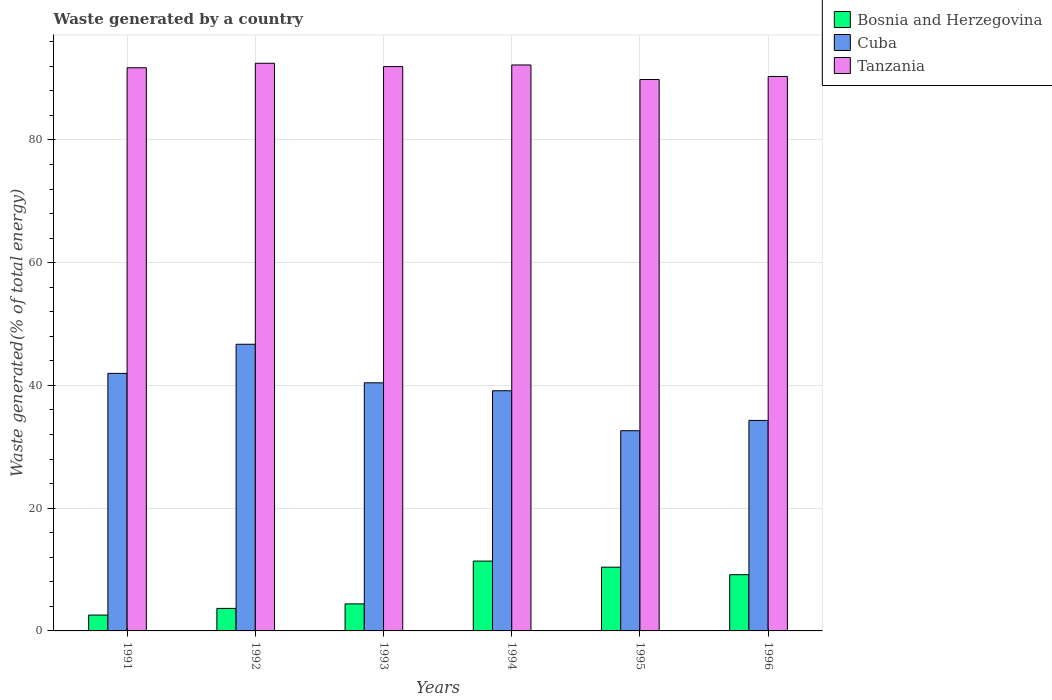How many different coloured bars are there?
Your response must be concise. 3. What is the total waste generated in Bosnia and Herzegovina in 1994?
Provide a short and direct response. 11.38. Across all years, what is the maximum total waste generated in Cuba?
Your answer should be compact. 46.7. Across all years, what is the minimum total waste generated in Bosnia and Herzegovina?
Offer a very short reply. 2.59. In which year was the total waste generated in Cuba maximum?
Your answer should be very brief. 1992. What is the total total waste generated in Cuba in the graph?
Your response must be concise. 235.14. What is the difference between the total waste generated in Tanzania in 1994 and that in 1996?
Provide a short and direct response. 1.87. What is the difference between the total waste generated in Cuba in 1991 and the total waste generated in Bosnia and Herzegovina in 1995?
Provide a short and direct response. 31.57. What is the average total waste generated in Tanzania per year?
Offer a very short reply. 91.43. In the year 1991, what is the difference between the total waste generated in Cuba and total waste generated in Tanzania?
Offer a terse response. -49.79. In how many years, is the total waste generated in Tanzania greater than 32 %?
Ensure brevity in your answer.  6. What is the ratio of the total waste generated in Cuba in 1991 to that in 1994?
Give a very brief answer. 1.07. What is the difference between the highest and the second highest total waste generated in Tanzania?
Offer a terse response. 0.28. What is the difference between the highest and the lowest total waste generated in Tanzania?
Ensure brevity in your answer.  2.65. Is the sum of the total waste generated in Bosnia and Herzegovina in 1991 and 1994 greater than the maximum total waste generated in Tanzania across all years?
Ensure brevity in your answer.  No. What does the 3rd bar from the left in 1996 represents?
Make the answer very short. Tanzania. What does the 2nd bar from the right in 1993 represents?
Provide a short and direct response. Cuba. How many bars are there?
Your response must be concise. 18. How many years are there in the graph?
Offer a very short reply. 6. Are the values on the major ticks of Y-axis written in scientific E-notation?
Your response must be concise. No. Does the graph contain any zero values?
Your response must be concise. No. Does the graph contain grids?
Your answer should be very brief. Yes. Where does the legend appear in the graph?
Ensure brevity in your answer.  Top right. How are the legend labels stacked?
Provide a short and direct response. Vertical. What is the title of the graph?
Offer a very short reply. Waste generated by a country. What is the label or title of the X-axis?
Provide a short and direct response. Years. What is the label or title of the Y-axis?
Provide a succinct answer. Waste generated(% of total energy). What is the Waste generated(% of total energy) of Bosnia and Herzegovina in 1991?
Provide a short and direct response. 2.59. What is the Waste generated(% of total energy) in Cuba in 1991?
Offer a very short reply. 41.96. What is the Waste generated(% of total energy) of Tanzania in 1991?
Offer a very short reply. 91.75. What is the Waste generated(% of total energy) in Bosnia and Herzegovina in 1992?
Your answer should be very brief. 3.67. What is the Waste generated(% of total energy) of Cuba in 1992?
Provide a succinct answer. 46.7. What is the Waste generated(% of total energy) of Tanzania in 1992?
Your answer should be very brief. 92.49. What is the Waste generated(% of total energy) of Bosnia and Herzegovina in 1993?
Keep it short and to the point. 4.41. What is the Waste generated(% of total energy) in Cuba in 1993?
Your answer should be very brief. 40.42. What is the Waste generated(% of total energy) of Tanzania in 1993?
Keep it short and to the point. 91.94. What is the Waste generated(% of total energy) of Bosnia and Herzegovina in 1994?
Keep it short and to the point. 11.38. What is the Waste generated(% of total energy) of Cuba in 1994?
Offer a very short reply. 39.13. What is the Waste generated(% of total energy) in Tanzania in 1994?
Keep it short and to the point. 92.21. What is the Waste generated(% of total energy) in Bosnia and Herzegovina in 1995?
Make the answer very short. 10.39. What is the Waste generated(% of total energy) in Cuba in 1995?
Your answer should be compact. 32.62. What is the Waste generated(% of total energy) in Tanzania in 1995?
Your answer should be compact. 89.84. What is the Waste generated(% of total energy) in Bosnia and Herzegovina in 1996?
Your answer should be compact. 9.16. What is the Waste generated(% of total energy) in Cuba in 1996?
Make the answer very short. 34.3. What is the Waste generated(% of total energy) of Tanzania in 1996?
Provide a short and direct response. 90.34. Across all years, what is the maximum Waste generated(% of total energy) of Bosnia and Herzegovina?
Provide a succinct answer. 11.38. Across all years, what is the maximum Waste generated(% of total energy) in Cuba?
Your response must be concise. 46.7. Across all years, what is the maximum Waste generated(% of total energy) of Tanzania?
Offer a terse response. 92.49. Across all years, what is the minimum Waste generated(% of total energy) in Bosnia and Herzegovina?
Keep it short and to the point. 2.59. Across all years, what is the minimum Waste generated(% of total energy) of Cuba?
Your answer should be compact. 32.62. Across all years, what is the minimum Waste generated(% of total energy) in Tanzania?
Ensure brevity in your answer.  89.84. What is the total Waste generated(% of total energy) in Bosnia and Herzegovina in the graph?
Offer a very short reply. 41.59. What is the total Waste generated(% of total energy) of Cuba in the graph?
Keep it short and to the point. 235.14. What is the total Waste generated(% of total energy) in Tanzania in the graph?
Offer a terse response. 548.57. What is the difference between the Waste generated(% of total energy) in Bosnia and Herzegovina in 1991 and that in 1992?
Your response must be concise. -1.09. What is the difference between the Waste generated(% of total energy) of Cuba in 1991 and that in 1992?
Your response must be concise. -4.74. What is the difference between the Waste generated(% of total energy) of Tanzania in 1991 and that in 1992?
Your answer should be compact. -0.73. What is the difference between the Waste generated(% of total energy) in Bosnia and Herzegovina in 1991 and that in 1993?
Your answer should be compact. -1.82. What is the difference between the Waste generated(% of total energy) of Cuba in 1991 and that in 1993?
Offer a very short reply. 1.54. What is the difference between the Waste generated(% of total energy) of Tanzania in 1991 and that in 1993?
Provide a short and direct response. -0.19. What is the difference between the Waste generated(% of total energy) in Bosnia and Herzegovina in 1991 and that in 1994?
Ensure brevity in your answer.  -8.79. What is the difference between the Waste generated(% of total energy) of Cuba in 1991 and that in 1994?
Give a very brief answer. 2.83. What is the difference between the Waste generated(% of total energy) in Tanzania in 1991 and that in 1994?
Your answer should be compact. -0.46. What is the difference between the Waste generated(% of total energy) of Bosnia and Herzegovina in 1991 and that in 1995?
Provide a short and direct response. -7.8. What is the difference between the Waste generated(% of total energy) in Cuba in 1991 and that in 1995?
Your answer should be very brief. 9.34. What is the difference between the Waste generated(% of total energy) in Tanzania in 1991 and that in 1995?
Provide a succinct answer. 1.92. What is the difference between the Waste generated(% of total energy) in Bosnia and Herzegovina in 1991 and that in 1996?
Ensure brevity in your answer.  -6.58. What is the difference between the Waste generated(% of total energy) in Cuba in 1991 and that in 1996?
Your answer should be very brief. 7.66. What is the difference between the Waste generated(% of total energy) of Tanzania in 1991 and that in 1996?
Ensure brevity in your answer.  1.42. What is the difference between the Waste generated(% of total energy) in Bosnia and Herzegovina in 1992 and that in 1993?
Make the answer very short. -0.74. What is the difference between the Waste generated(% of total energy) in Cuba in 1992 and that in 1993?
Your answer should be very brief. 6.28. What is the difference between the Waste generated(% of total energy) of Tanzania in 1992 and that in 1993?
Ensure brevity in your answer.  0.54. What is the difference between the Waste generated(% of total energy) in Bosnia and Herzegovina in 1992 and that in 1994?
Keep it short and to the point. -7.71. What is the difference between the Waste generated(% of total energy) of Cuba in 1992 and that in 1994?
Provide a short and direct response. 7.57. What is the difference between the Waste generated(% of total energy) in Tanzania in 1992 and that in 1994?
Provide a succinct answer. 0.28. What is the difference between the Waste generated(% of total energy) of Bosnia and Herzegovina in 1992 and that in 1995?
Provide a succinct answer. -6.72. What is the difference between the Waste generated(% of total energy) of Cuba in 1992 and that in 1995?
Provide a short and direct response. 14.08. What is the difference between the Waste generated(% of total energy) of Tanzania in 1992 and that in 1995?
Offer a very short reply. 2.65. What is the difference between the Waste generated(% of total energy) in Bosnia and Herzegovina in 1992 and that in 1996?
Provide a short and direct response. -5.49. What is the difference between the Waste generated(% of total energy) of Cuba in 1992 and that in 1996?
Your response must be concise. 12.41. What is the difference between the Waste generated(% of total energy) of Tanzania in 1992 and that in 1996?
Your answer should be compact. 2.15. What is the difference between the Waste generated(% of total energy) of Bosnia and Herzegovina in 1993 and that in 1994?
Provide a short and direct response. -6.97. What is the difference between the Waste generated(% of total energy) of Cuba in 1993 and that in 1994?
Offer a terse response. 1.29. What is the difference between the Waste generated(% of total energy) in Tanzania in 1993 and that in 1994?
Provide a short and direct response. -0.26. What is the difference between the Waste generated(% of total energy) in Bosnia and Herzegovina in 1993 and that in 1995?
Give a very brief answer. -5.98. What is the difference between the Waste generated(% of total energy) in Cuba in 1993 and that in 1995?
Make the answer very short. 7.8. What is the difference between the Waste generated(% of total energy) of Tanzania in 1993 and that in 1995?
Ensure brevity in your answer.  2.11. What is the difference between the Waste generated(% of total energy) in Bosnia and Herzegovina in 1993 and that in 1996?
Keep it short and to the point. -4.76. What is the difference between the Waste generated(% of total energy) of Cuba in 1993 and that in 1996?
Ensure brevity in your answer.  6.13. What is the difference between the Waste generated(% of total energy) in Tanzania in 1993 and that in 1996?
Your answer should be compact. 1.61. What is the difference between the Waste generated(% of total energy) of Bosnia and Herzegovina in 1994 and that in 1995?
Provide a succinct answer. 0.99. What is the difference between the Waste generated(% of total energy) in Cuba in 1994 and that in 1995?
Your answer should be very brief. 6.51. What is the difference between the Waste generated(% of total energy) of Tanzania in 1994 and that in 1995?
Keep it short and to the point. 2.37. What is the difference between the Waste generated(% of total energy) in Bosnia and Herzegovina in 1994 and that in 1996?
Offer a very short reply. 2.22. What is the difference between the Waste generated(% of total energy) in Cuba in 1994 and that in 1996?
Your response must be concise. 4.83. What is the difference between the Waste generated(% of total energy) of Tanzania in 1994 and that in 1996?
Ensure brevity in your answer.  1.87. What is the difference between the Waste generated(% of total energy) of Bosnia and Herzegovina in 1995 and that in 1996?
Keep it short and to the point. 1.23. What is the difference between the Waste generated(% of total energy) of Cuba in 1995 and that in 1996?
Offer a terse response. -1.68. What is the difference between the Waste generated(% of total energy) in Tanzania in 1995 and that in 1996?
Keep it short and to the point. -0.5. What is the difference between the Waste generated(% of total energy) of Bosnia and Herzegovina in 1991 and the Waste generated(% of total energy) of Cuba in 1992?
Provide a succinct answer. -44.12. What is the difference between the Waste generated(% of total energy) in Bosnia and Herzegovina in 1991 and the Waste generated(% of total energy) in Tanzania in 1992?
Keep it short and to the point. -89.9. What is the difference between the Waste generated(% of total energy) in Cuba in 1991 and the Waste generated(% of total energy) in Tanzania in 1992?
Make the answer very short. -50.52. What is the difference between the Waste generated(% of total energy) of Bosnia and Herzegovina in 1991 and the Waste generated(% of total energy) of Cuba in 1993?
Provide a succinct answer. -37.84. What is the difference between the Waste generated(% of total energy) of Bosnia and Herzegovina in 1991 and the Waste generated(% of total energy) of Tanzania in 1993?
Keep it short and to the point. -89.36. What is the difference between the Waste generated(% of total energy) of Cuba in 1991 and the Waste generated(% of total energy) of Tanzania in 1993?
Give a very brief answer. -49.98. What is the difference between the Waste generated(% of total energy) in Bosnia and Herzegovina in 1991 and the Waste generated(% of total energy) in Cuba in 1994?
Provide a succinct answer. -36.55. What is the difference between the Waste generated(% of total energy) in Bosnia and Herzegovina in 1991 and the Waste generated(% of total energy) in Tanzania in 1994?
Your answer should be very brief. -89.62. What is the difference between the Waste generated(% of total energy) in Cuba in 1991 and the Waste generated(% of total energy) in Tanzania in 1994?
Ensure brevity in your answer.  -50.25. What is the difference between the Waste generated(% of total energy) in Bosnia and Herzegovina in 1991 and the Waste generated(% of total energy) in Cuba in 1995?
Offer a very short reply. -30.03. What is the difference between the Waste generated(% of total energy) of Bosnia and Herzegovina in 1991 and the Waste generated(% of total energy) of Tanzania in 1995?
Provide a succinct answer. -87.25. What is the difference between the Waste generated(% of total energy) of Cuba in 1991 and the Waste generated(% of total energy) of Tanzania in 1995?
Your answer should be very brief. -47.87. What is the difference between the Waste generated(% of total energy) of Bosnia and Herzegovina in 1991 and the Waste generated(% of total energy) of Cuba in 1996?
Provide a short and direct response. -31.71. What is the difference between the Waste generated(% of total energy) of Bosnia and Herzegovina in 1991 and the Waste generated(% of total energy) of Tanzania in 1996?
Ensure brevity in your answer.  -87.75. What is the difference between the Waste generated(% of total energy) of Cuba in 1991 and the Waste generated(% of total energy) of Tanzania in 1996?
Offer a very short reply. -48.37. What is the difference between the Waste generated(% of total energy) of Bosnia and Herzegovina in 1992 and the Waste generated(% of total energy) of Cuba in 1993?
Make the answer very short. -36.75. What is the difference between the Waste generated(% of total energy) in Bosnia and Herzegovina in 1992 and the Waste generated(% of total energy) in Tanzania in 1993?
Make the answer very short. -88.27. What is the difference between the Waste generated(% of total energy) in Cuba in 1992 and the Waste generated(% of total energy) in Tanzania in 1993?
Provide a short and direct response. -45.24. What is the difference between the Waste generated(% of total energy) of Bosnia and Herzegovina in 1992 and the Waste generated(% of total energy) of Cuba in 1994?
Your answer should be compact. -35.46. What is the difference between the Waste generated(% of total energy) in Bosnia and Herzegovina in 1992 and the Waste generated(% of total energy) in Tanzania in 1994?
Offer a very short reply. -88.54. What is the difference between the Waste generated(% of total energy) of Cuba in 1992 and the Waste generated(% of total energy) of Tanzania in 1994?
Offer a terse response. -45.5. What is the difference between the Waste generated(% of total energy) of Bosnia and Herzegovina in 1992 and the Waste generated(% of total energy) of Cuba in 1995?
Keep it short and to the point. -28.95. What is the difference between the Waste generated(% of total energy) in Bosnia and Herzegovina in 1992 and the Waste generated(% of total energy) in Tanzania in 1995?
Your answer should be very brief. -86.17. What is the difference between the Waste generated(% of total energy) of Cuba in 1992 and the Waste generated(% of total energy) of Tanzania in 1995?
Provide a short and direct response. -43.13. What is the difference between the Waste generated(% of total energy) of Bosnia and Herzegovina in 1992 and the Waste generated(% of total energy) of Cuba in 1996?
Offer a terse response. -30.63. What is the difference between the Waste generated(% of total energy) in Bosnia and Herzegovina in 1992 and the Waste generated(% of total energy) in Tanzania in 1996?
Give a very brief answer. -86.67. What is the difference between the Waste generated(% of total energy) of Cuba in 1992 and the Waste generated(% of total energy) of Tanzania in 1996?
Provide a succinct answer. -43.63. What is the difference between the Waste generated(% of total energy) of Bosnia and Herzegovina in 1993 and the Waste generated(% of total energy) of Cuba in 1994?
Give a very brief answer. -34.73. What is the difference between the Waste generated(% of total energy) of Bosnia and Herzegovina in 1993 and the Waste generated(% of total energy) of Tanzania in 1994?
Offer a terse response. -87.8. What is the difference between the Waste generated(% of total energy) of Cuba in 1993 and the Waste generated(% of total energy) of Tanzania in 1994?
Your answer should be very brief. -51.78. What is the difference between the Waste generated(% of total energy) of Bosnia and Herzegovina in 1993 and the Waste generated(% of total energy) of Cuba in 1995?
Keep it short and to the point. -28.21. What is the difference between the Waste generated(% of total energy) in Bosnia and Herzegovina in 1993 and the Waste generated(% of total energy) in Tanzania in 1995?
Offer a terse response. -85.43. What is the difference between the Waste generated(% of total energy) of Cuba in 1993 and the Waste generated(% of total energy) of Tanzania in 1995?
Make the answer very short. -49.41. What is the difference between the Waste generated(% of total energy) of Bosnia and Herzegovina in 1993 and the Waste generated(% of total energy) of Cuba in 1996?
Your answer should be very brief. -29.89. What is the difference between the Waste generated(% of total energy) of Bosnia and Herzegovina in 1993 and the Waste generated(% of total energy) of Tanzania in 1996?
Offer a terse response. -85.93. What is the difference between the Waste generated(% of total energy) of Cuba in 1993 and the Waste generated(% of total energy) of Tanzania in 1996?
Ensure brevity in your answer.  -49.91. What is the difference between the Waste generated(% of total energy) of Bosnia and Herzegovina in 1994 and the Waste generated(% of total energy) of Cuba in 1995?
Ensure brevity in your answer.  -21.24. What is the difference between the Waste generated(% of total energy) of Bosnia and Herzegovina in 1994 and the Waste generated(% of total energy) of Tanzania in 1995?
Keep it short and to the point. -78.46. What is the difference between the Waste generated(% of total energy) in Cuba in 1994 and the Waste generated(% of total energy) in Tanzania in 1995?
Ensure brevity in your answer.  -50.71. What is the difference between the Waste generated(% of total energy) of Bosnia and Herzegovina in 1994 and the Waste generated(% of total energy) of Cuba in 1996?
Offer a very short reply. -22.92. What is the difference between the Waste generated(% of total energy) of Bosnia and Herzegovina in 1994 and the Waste generated(% of total energy) of Tanzania in 1996?
Make the answer very short. -78.96. What is the difference between the Waste generated(% of total energy) of Cuba in 1994 and the Waste generated(% of total energy) of Tanzania in 1996?
Your answer should be compact. -51.21. What is the difference between the Waste generated(% of total energy) in Bosnia and Herzegovina in 1995 and the Waste generated(% of total energy) in Cuba in 1996?
Offer a very short reply. -23.91. What is the difference between the Waste generated(% of total energy) in Bosnia and Herzegovina in 1995 and the Waste generated(% of total energy) in Tanzania in 1996?
Make the answer very short. -79.95. What is the difference between the Waste generated(% of total energy) in Cuba in 1995 and the Waste generated(% of total energy) in Tanzania in 1996?
Your response must be concise. -57.72. What is the average Waste generated(% of total energy) of Bosnia and Herzegovina per year?
Your response must be concise. 6.93. What is the average Waste generated(% of total energy) of Cuba per year?
Your answer should be compact. 39.19. What is the average Waste generated(% of total energy) of Tanzania per year?
Offer a terse response. 91.43. In the year 1991, what is the difference between the Waste generated(% of total energy) of Bosnia and Herzegovina and Waste generated(% of total energy) of Cuba?
Provide a succinct answer. -39.38. In the year 1991, what is the difference between the Waste generated(% of total energy) in Bosnia and Herzegovina and Waste generated(% of total energy) in Tanzania?
Offer a very short reply. -89.17. In the year 1991, what is the difference between the Waste generated(% of total energy) of Cuba and Waste generated(% of total energy) of Tanzania?
Keep it short and to the point. -49.79. In the year 1992, what is the difference between the Waste generated(% of total energy) of Bosnia and Herzegovina and Waste generated(% of total energy) of Cuba?
Provide a succinct answer. -43.03. In the year 1992, what is the difference between the Waste generated(% of total energy) in Bosnia and Herzegovina and Waste generated(% of total energy) in Tanzania?
Your answer should be very brief. -88.82. In the year 1992, what is the difference between the Waste generated(% of total energy) in Cuba and Waste generated(% of total energy) in Tanzania?
Offer a terse response. -45.78. In the year 1993, what is the difference between the Waste generated(% of total energy) in Bosnia and Herzegovina and Waste generated(% of total energy) in Cuba?
Give a very brief answer. -36.02. In the year 1993, what is the difference between the Waste generated(% of total energy) in Bosnia and Herzegovina and Waste generated(% of total energy) in Tanzania?
Ensure brevity in your answer.  -87.54. In the year 1993, what is the difference between the Waste generated(% of total energy) of Cuba and Waste generated(% of total energy) of Tanzania?
Ensure brevity in your answer.  -51.52. In the year 1994, what is the difference between the Waste generated(% of total energy) of Bosnia and Herzegovina and Waste generated(% of total energy) of Cuba?
Your response must be concise. -27.75. In the year 1994, what is the difference between the Waste generated(% of total energy) in Bosnia and Herzegovina and Waste generated(% of total energy) in Tanzania?
Your response must be concise. -80.83. In the year 1994, what is the difference between the Waste generated(% of total energy) of Cuba and Waste generated(% of total energy) of Tanzania?
Make the answer very short. -53.08. In the year 1995, what is the difference between the Waste generated(% of total energy) of Bosnia and Herzegovina and Waste generated(% of total energy) of Cuba?
Ensure brevity in your answer.  -22.23. In the year 1995, what is the difference between the Waste generated(% of total energy) in Bosnia and Herzegovina and Waste generated(% of total energy) in Tanzania?
Offer a terse response. -79.45. In the year 1995, what is the difference between the Waste generated(% of total energy) in Cuba and Waste generated(% of total energy) in Tanzania?
Ensure brevity in your answer.  -57.22. In the year 1996, what is the difference between the Waste generated(% of total energy) of Bosnia and Herzegovina and Waste generated(% of total energy) of Cuba?
Your answer should be compact. -25.14. In the year 1996, what is the difference between the Waste generated(% of total energy) in Bosnia and Herzegovina and Waste generated(% of total energy) in Tanzania?
Offer a terse response. -81.17. In the year 1996, what is the difference between the Waste generated(% of total energy) in Cuba and Waste generated(% of total energy) in Tanzania?
Provide a succinct answer. -56.04. What is the ratio of the Waste generated(% of total energy) of Bosnia and Herzegovina in 1991 to that in 1992?
Make the answer very short. 0.7. What is the ratio of the Waste generated(% of total energy) in Cuba in 1991 to that in 1992?
Offer a terse response. 0.9. What is the ratio of the Waste generated(% of total energy) in Bosnia and Herzegovina in 1991 to that in 1993?
Your answer should be compact. 0.59. What is the ratio of the Waste generated(% of total energy) in Cuba in 1991 to that in 1993?
Keep it short and to the point. 1.04. What is the ratio of the Waste generated(% of total energy) of Tanzania in 1991 to that in 1993?
Provide a short and direct response. 1. What is the ratio of the Waste generated(% of total energy) of Bosnia and Herzegovina in 1991 to that in 1994?
Offer a very short reply. 0.23. What is the ratio of the Waste generated(% of total energy) in Cuba in 1991 to that in 1994?
Provide a succinct answer. 1.07. What is the ratio of the Waste generated(% of total energy) in Bosnia and Herzegovina in 1991 to that in 1995?
Make the answer very short. 0.25. What is the ratio of the Waste generated(% of total energy) in Cuba in 1991 to that in 1995?
Provide a succinct answer. 1.29. What is the ratio of the Waste generated(% of total energy) of Tanzania in 1991 to that in 1995?
Provide a succinct answer. 1.02. What is the ratio of the Waste generated(% of total energy) of Bosnia and Herzegovina in 1991 to that in 1996?
Keep it short and to the point. 0.28. What is the ratio of the Waste generated(% of total energy) in Cuba in 1991 to that in 1996?
Give a very brief answer. 1.22. What is the ratio of the Waste generated(% of total energy) of Tanzania in 1991 to that in 1996?
Offer a terse response. 1.02. What is the ratio of the Waste generated(% of total energy) of Bosnia and Herzegovina in 1992 to that in 1993?
Keep it short and to the point. 0.83. What is the ratio of the Waste generated(% of total energy) in Cuba in 1992 to that in 1993?
Ensure brevity in your answer.  1.16. What is the ratio of the Waste generated(% of total energy) of Tanzania in 1992 to that in 1993?
Provide a short and direct response. 1.01. What is the ratio of the Waste generated(% of total energy) in Bosnia and Herzegovina in 1992 to that in 1994?
Provide a succinct answer. 0.32. What is the ratio of the Waste generated(% of total energy) in Cuba in 1992 to that in 1994?
Your answer should be very brief. 1.19. What is the ratio of the Waste generated(% of total energy) of Tanzania in 1992 to that in 1994?
Your response must be concise. 1. What is the ratio of the Waste generated(% of total energy) in Bosnia and Herzegovina in 1992 to that in 1995?
Offer a very short reply. 0.35. What is the ratio of the Waste generated(% of total energy) of Cuba in 1992 to that in 1995?
Your response must be concise. 1.43. What is the ratio of the Waste generated(% of total energy) of Tanzania in 1992 to that in 1995?
Keep it short and to the point. 1.03. What is the ratio of the Waste generated(% of total energy) in Bosnia and Herzegovina in 1992 to that in 1996?
Ensure brevity in your answer.  0.4. What is the ratio of the Waste generated(% of total energy) in Cuba in 1992 to that in 1996?
Ensure brevity in your answer.  1.36. What is the ratio of the Waste generated(% of total energy) of Tanzania in 1992 to that in 1996?
Make the answer very short. 1.02. What is the ratio of the Waste generated(% of total energy) in Bosnia and Herzegovina in 1993 to that in 1994?
Your answer should be compact. 0.39. What is the ratio of the Waste generated(% of total energy) in Cuba in 1993 to that in 1994?
Your answer should be compact. 1.03. What is the ratio of the Waste generated(% of total energy) of Tanzania in 1993 to that in 1994?
Ensure brevity in your answer.  1. What is the ratio of the Waste generated(% of total energy) in Bosnia and Herzegovina in 1993 to that in 1995?
Give a very brief answer. 0.42. What is the ratio of the Waste generated(% of total energy) in Cuba in 1993 to that in 1995?
Your answer should be compact. 1.24. What is the ratio of the Waste generated(% of total energy) in Tanzania in 1993 to that in 1995?
Your response must be concise. 1.02. What is the ratio of the Waste generated(% of total energy) of Bosnia and Herzegovina in 1993 to that in 1996?
Offer a terse response. 0.48. What is the ratio of the Waste generated(% of total energy) of Cuba in 1993 to that in 1996?
Give a very brief answer. 1.18. What is the ratio of the Waste generated(% of total energy) in Tanzania in 1993 to that in 1996?
Your answer should be compact. 1.02. What is the ratio of the Waste generated(% of total energy) in Bosnia and Herzegovina in 1994 to that in 1995?
Ensure brevity in your answer.  1.1. What is the ratio of the Waste generated(% of total energy) of Cuba in 1994 to that in 1995?
Your answer should be compact. 1.2. What is the ratio of the Waste generated(% of total energy) of Tanzania in 1994 to that in 1995?
Ensure brevity in your answer.  1.03. What is the ratio of the Waste generated(% of total energy) in Bosnia and Herzegovina in 1994 to that in 1996?
Provide a short and direct response. 1.24. What is the ratio of the Waste generated(% of total energy) in Cuba in 1994 to that in 1996?
Give a very brief answer. 1.14. What is the ratio of the Waste generated(% of total energy) in Tanzania in 1994 to that in 1996?
Ensure brevity in your answer.  1.02. What is the ratio of the Waste generated(% of total energy) in Bosnia and Herzegovina in 1995 to that in 1996?
Offer a very short reply. 1.13. What is the ratio of the Waste generated(% of total energy) in Cuba in 1995 to that in 1996?
Make the answer very short. 0.95. What is the difference between the highest and the second highest Waste generated(% of total energy) of Cuba?
Ensure brevity in your answer.  4.74. What is the difference between the highest and the second highest Waste generated(% of total energy) in Tanzania?
Your answer should be compact. 0.28. What is the difference between the highest and the lowest Waste generated(% of total energy) of Bosnia and Herzegovina?
Offer a very short reply. 8.79. What is the difference between the highest and the lowest Waste generated(% of total energy) in Cuba?
Your answer should be compact. 14.08. What is the difference between the highest and the lowest Waste generated(% of total energy) of Tanzania?
Provide a short and direct response. 2.65. 